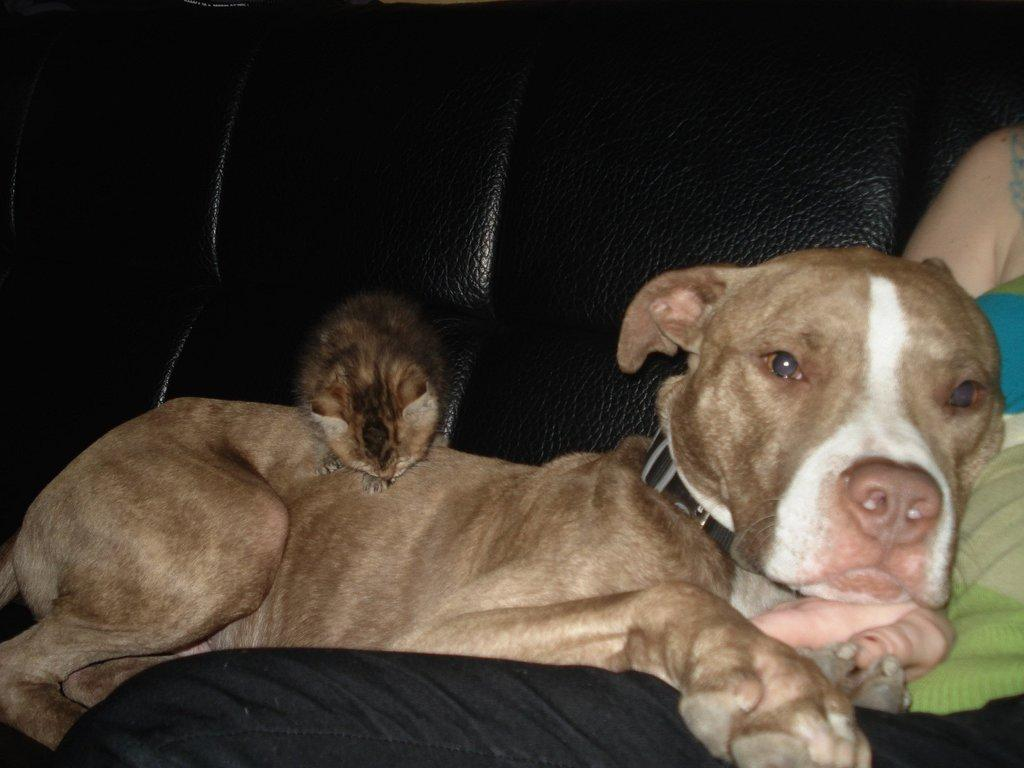What is the person in the image doing? The person is seated on the sofa in the image. What is beside the person? There is a dog beside the person. Are there any other animals in the image? Yes, there is another animal present in the image. What type of dust can be seen on the sofa in the image? There is no dust visible on the sofa in the image. How many beads are present on the dog in the image? There are no beads present on the dog in the image. 